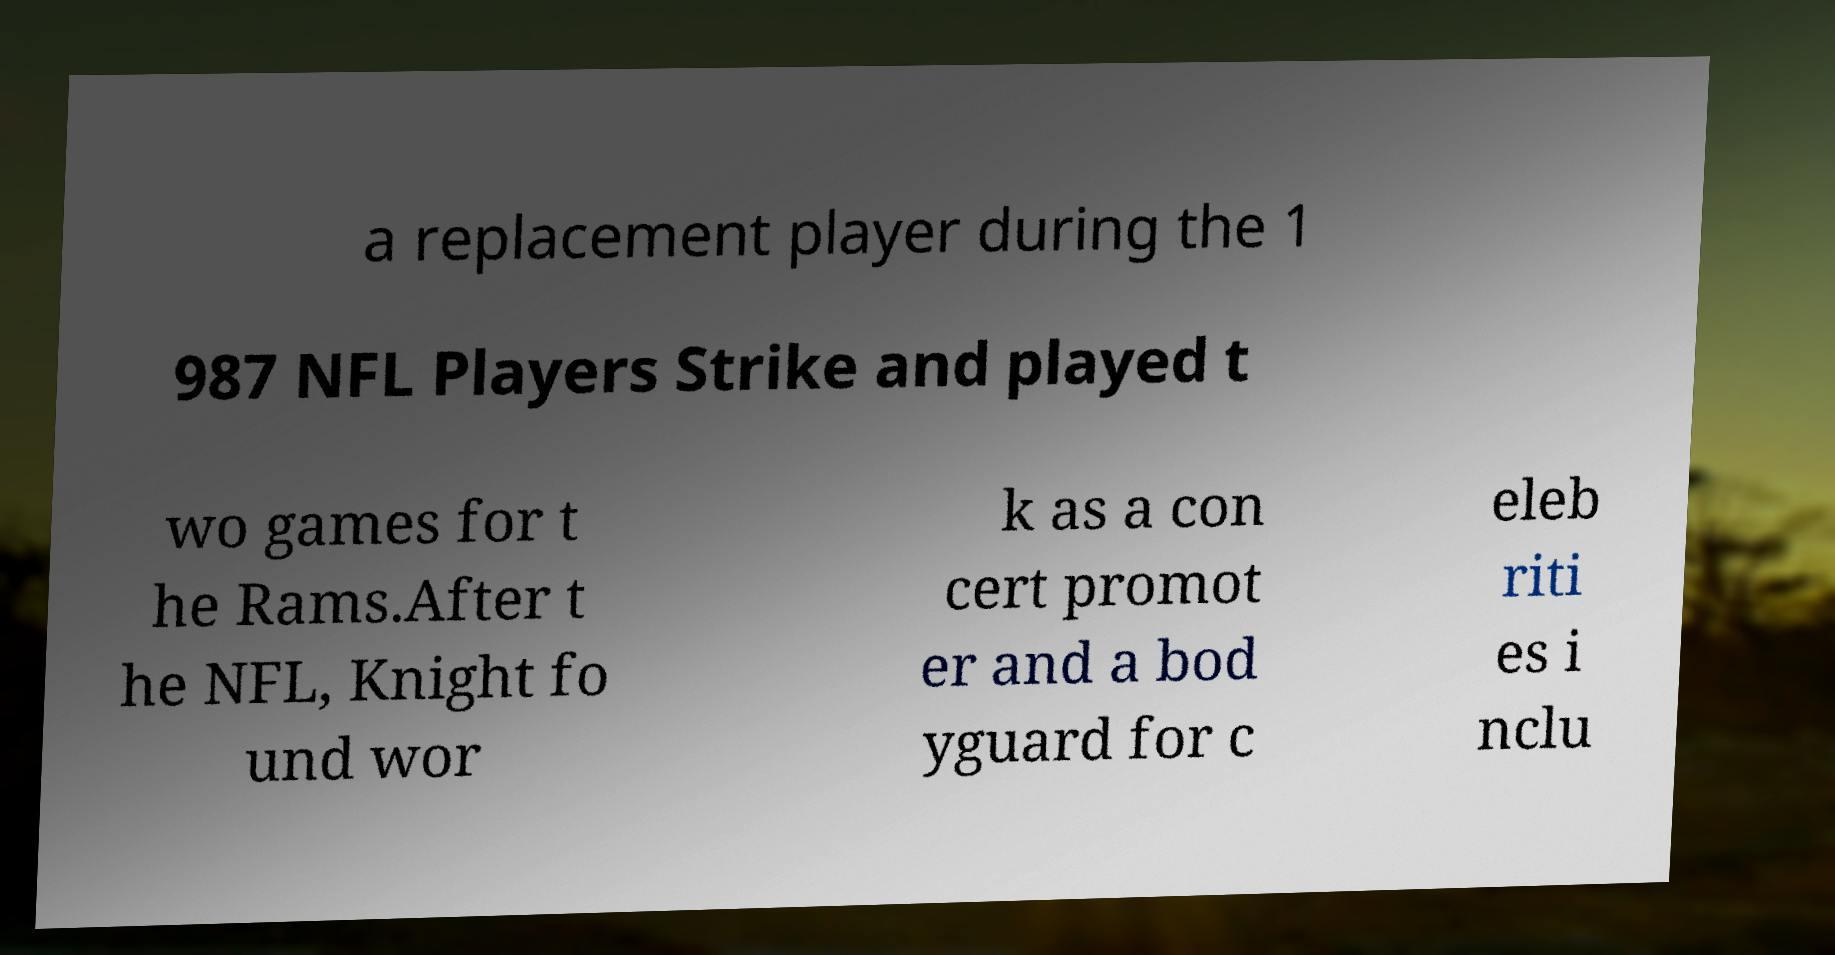What messages or text are displayed in this image? I need them in a readable, typed format. a replacement player during the 1 987 NFL Players Strike and played t wo games for t he Rams.After t he NFL, Knight fo und wor k as a con cert promot er and a bod yguard for c eleb riti es i nclu 